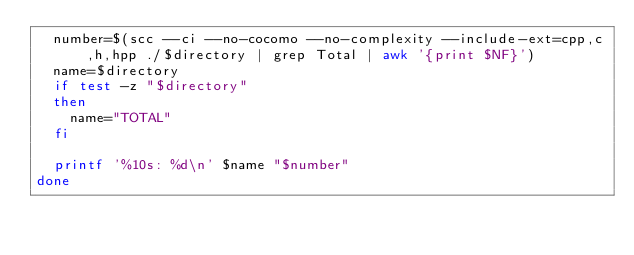<code> <loc_0><loc_0><loc_500><loc_500><_Bash_>	number=$(scc --ci --no-cocomo --no-complexity --include-ext=cpp,c,h,hpp ./$directory | grep Total | awk '{print $NF}')
	name=$directory
	if test -z "$directory"
	then
		name="TOTAL"
	fi

	printf '%10s: %d\n' $name "$number"
done
</code> 